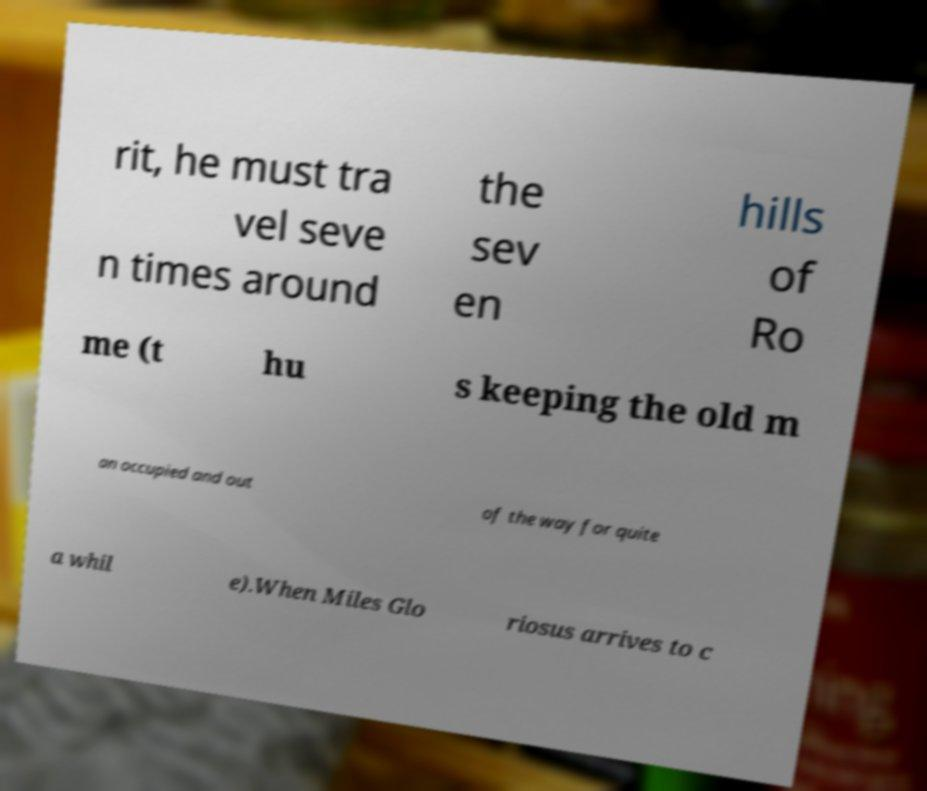For documentation purposes, I need the text within this image transcribed. Could you provide that? rit, he must tra vel seve n times around the sev en hills of Ro me (t hu s keeping the old m an occupied and out of the way for quite a whil e).When Miles Glo riosus arrives to c 